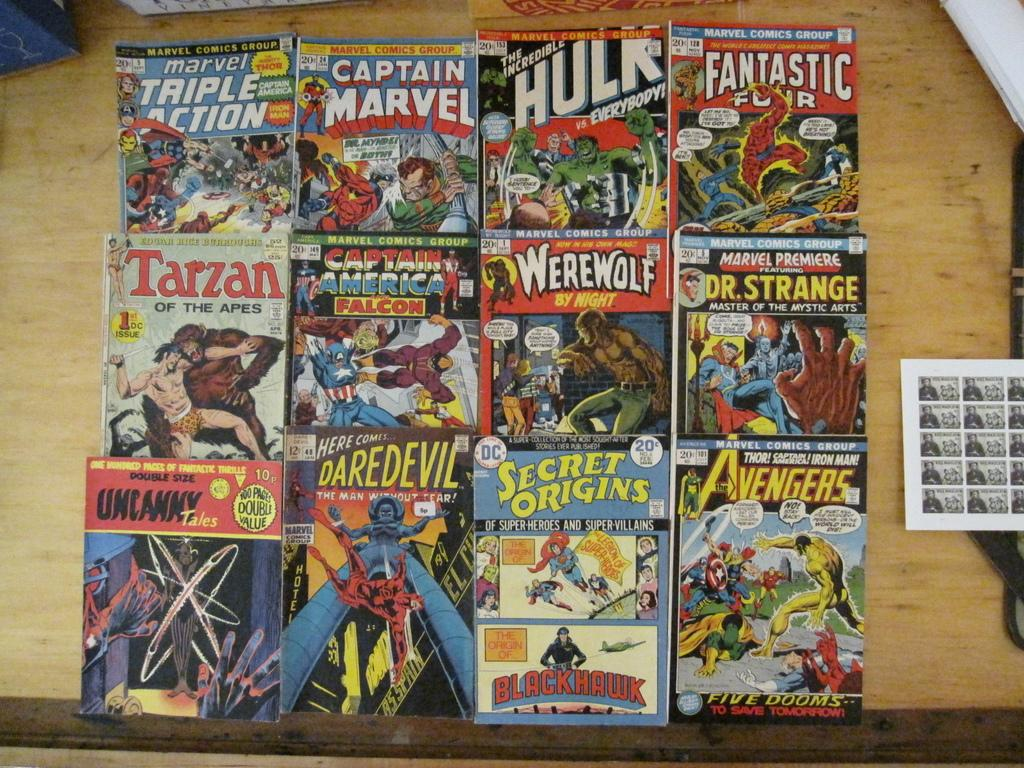<image>
Render a clear and concise summary of the photo. Several comic books such as Ware Wolf, Tarzan, and Fantastic Four are neatly placed on a table. 